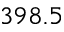<formula> <loc_0><loc_0><loc_500><loc_500>3 9 8 . 5</formula> 